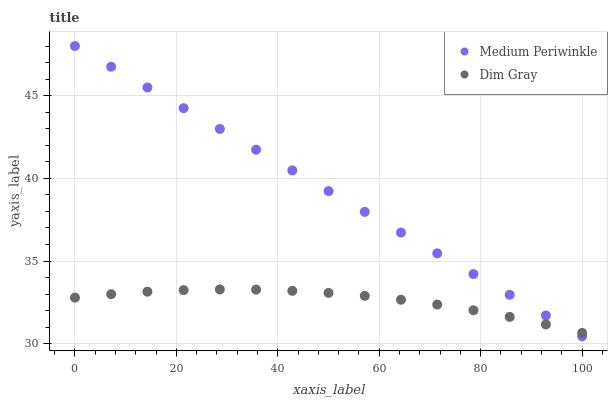Does Dim Gray have the minimum area under the curve?
Answer yes or no. Yes. Does Medium Periwinkle have the maximum area under the curve?
Answer yes or no. Yes. Does Medium Periwinkle have the minimum area under the curve?
Answer yes or no. No. Is Medium Periwinkle the smoothest?
Answer yes or no. Yes. Is Dim Gray the roughest?
Answer yes or no. Yes. Is Medium Periwinkle the roughest?
Answer yes or no. No. Does Medium Periwinkle have the lowest value?
Answer yes or no. Yes. Does Medium Periwinkle have the highest value?
Answer yes or no. Yes. Does Medium Periwinkle intersect Dim Gray?
Answer yes or no. Yes. Is Medium Periwinkle less than Dim Gray?
Answer yes or no. No. Is Medium Periwinkle greater than Dim Gray?
Answer yes or no. No. 